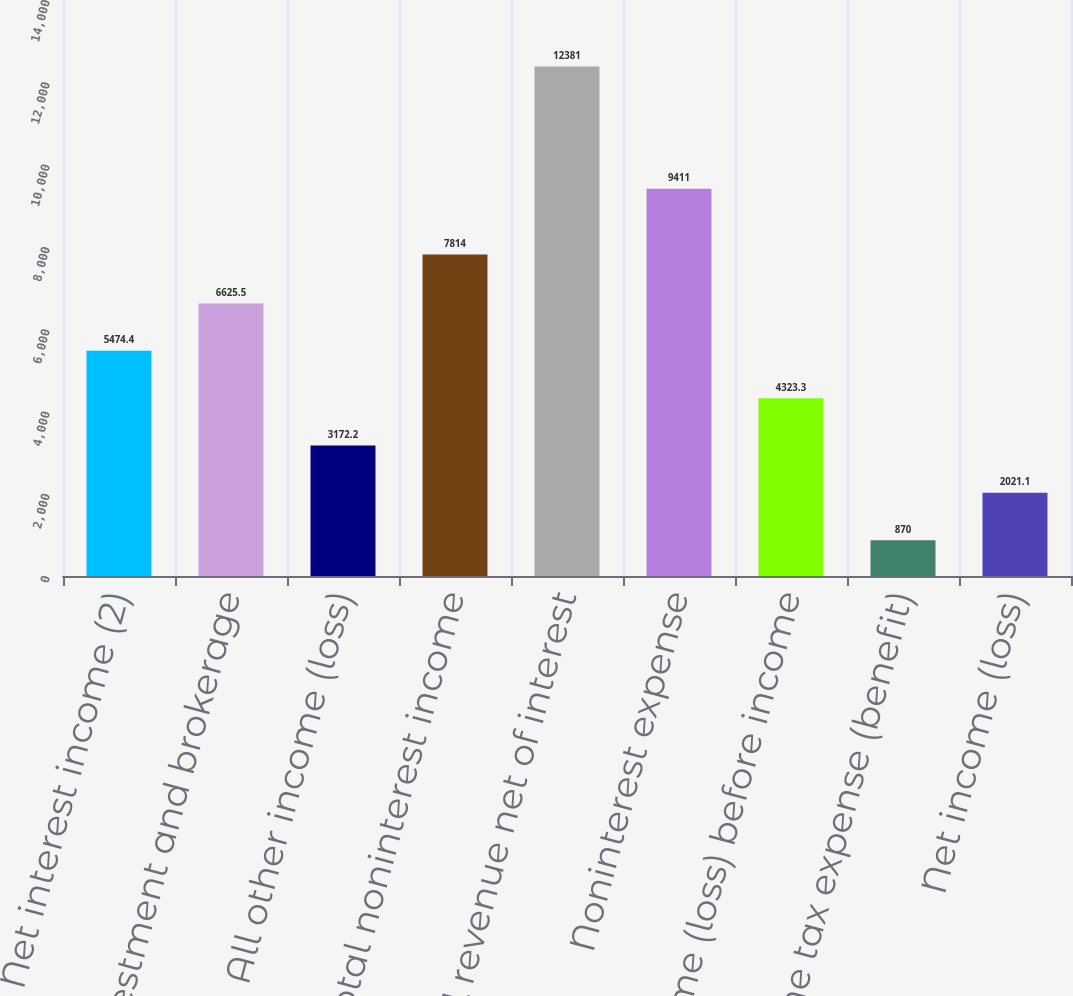Convert chart to OTSL. <chart><loc_0><loc_0><loc_500><loc_500><bar_chart><fcel>Net interest income (2)<fcel>Investment and brokerage<fcel>All other income (loss)<fcel>Total noninterest income<fcel>Total revenue net of interest<fcel>Noninterest expense<fcel>Income (loss) before income<fcel>Income tax expense (benefit)<fcel>Net income (loss)<nl><fcel>5474.4<fcel>6625.5<fcel>3172.2<fcel>7814<fcel>12381<fcel>9411<fcel>4323.3<fcel>870<fcel>2021.1<nl></chart> 